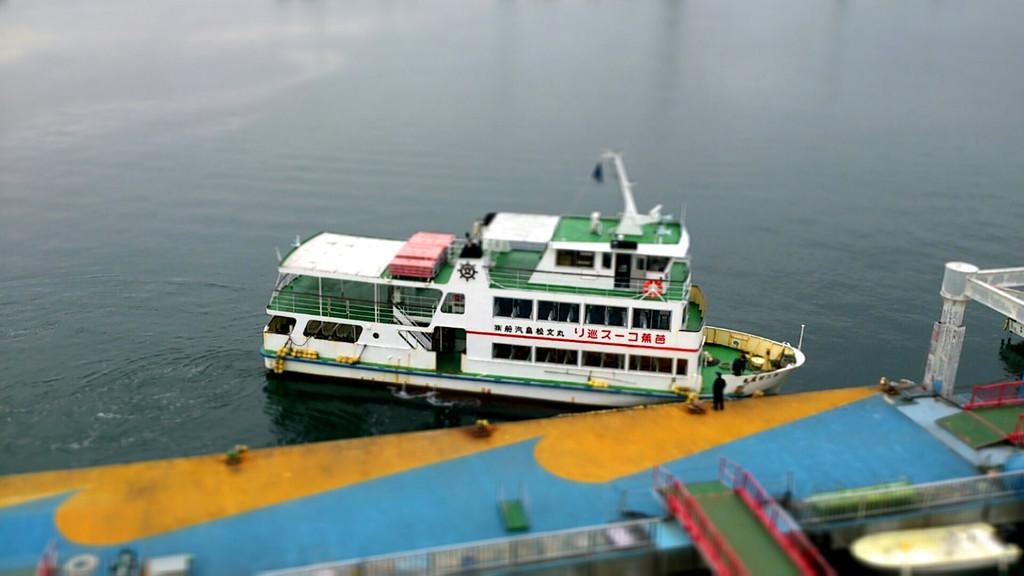What is the main subject in the center of the image? There is a boat in the center of the image. What type of environment is visible in the background of the image? There is water visible in the background of the image. What type of structure can be seen at the bottom of the image? There is a harbor at the bottom of the image. How many kittens are playing with a bucket in the cemetery in the image? There is no cemetery, bucket, or kittens present in the image. 